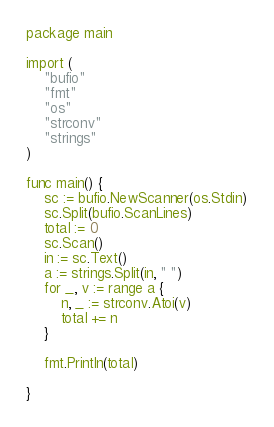<code> <loc_0><loc_0><loc_500><loc_500><_Go_>package main

import (
	"bufio"
	"fmt"
	"os"
	"strconv"
	"strings"
)

func main() {
	sc := bufio.NewScanner(os.Stdin)
	sc.Split(bufio.ScanLines)
	total := 0
	sc.Scan()
	in := sc.Text()
	a := strings.Split(in, " ")
	for _, v := range a {
		n, _ := strconv.Atoi(v)
		total += n
	}

	fmt.Println(total)

}

</code> 